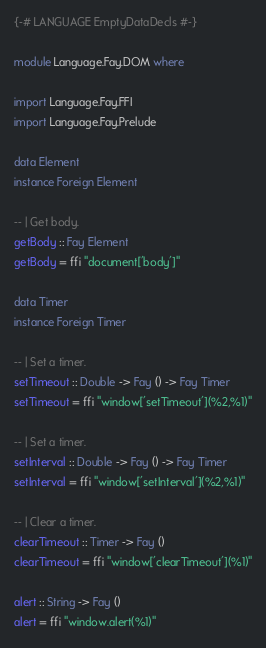<code> <loc_0><loc_0><loc_500><loc_500><_Haskell_>{-# LANGUAGE EmptyDataDecls #-}

module Language.Fay.DOM where

import Language.Fay.FFI
import Language.Fay.Prelude

data Element
instance Foreign Element

-- | Get body.
getBody :: Fay Element
getBody = ffi "document['body']"

data Timer
instance Foreign Timer

-- | Set a timer.
setTimeout :: Double -> Fay () -> Fay Timer
setTimeout = ffi "window['setTimeout'](%2,%1)"

-- | Set a timer.
setInterval :: Double -> Fay () -> Fay Timer
setInterval = ffi "window['setInterval'](%2,%1)"

-- | Clear a timer.
clearTimeout :: Timer -> Fay ()
clearTimeout = ffi "window['clearTimeout'](%1)"

alert :: String -> Fay ()
alert = ffi "window.alert(%1)"
</code> 